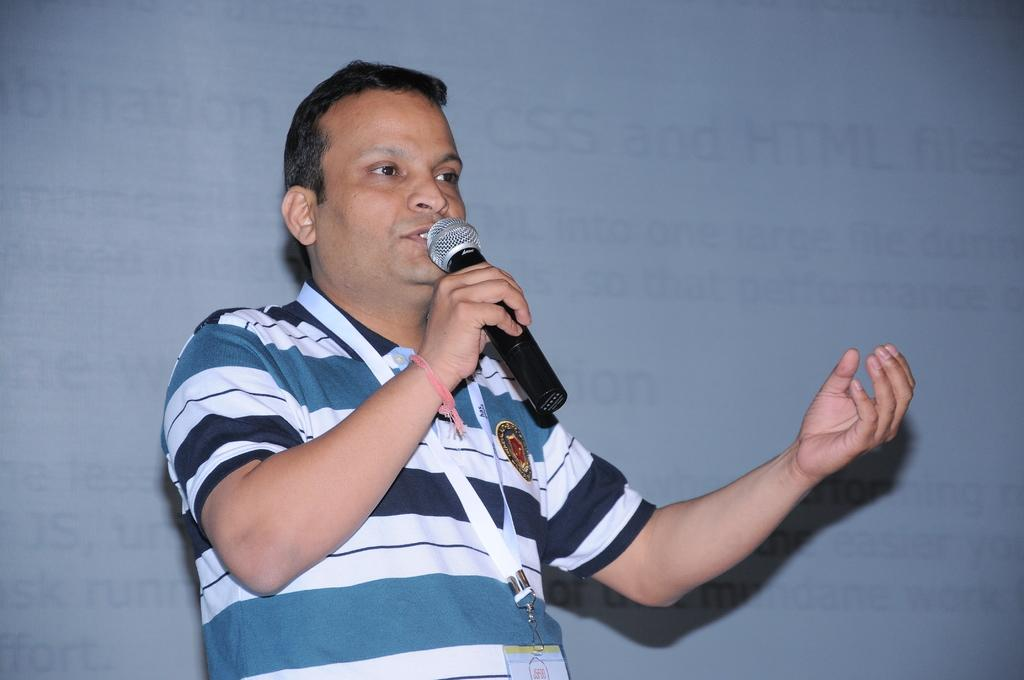What is the main subject of the image? The main subject of the image is a man. What is the man doing in the image? The man is standing and speaking with a microphone in his hand. Can you describe any additional details about the man? The man is wearing an ID card. What can be seen in the background of the image? There appears to be a projector screen with some text in the background. What type of twig is the man holding in the image? There is no twig present in the image; the man is holding a microphone. What is the title of the presentation being given by the man in the image? The provided facts do not mention a presentation or its title, so we cannot determine the title from the image. 